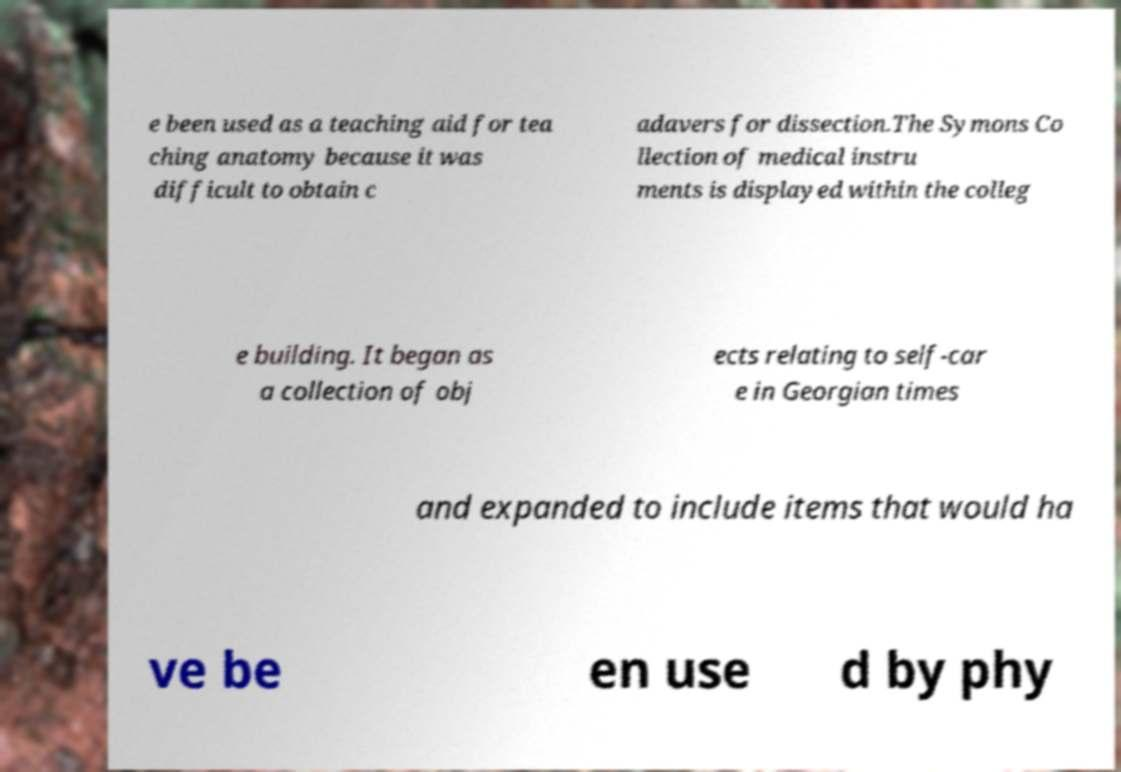Could you extract and type out the text from this image? e been used as a teaching aid for tea ching anatomy because it was difficult to obtain c adavers for dissection.The Symons Co llection of medical instru ments is displayed within the colleg e building. It began as a collection of obj ects relating to self-car e in Georgian times and expanded to include items that would ha ve be en use d by phy 